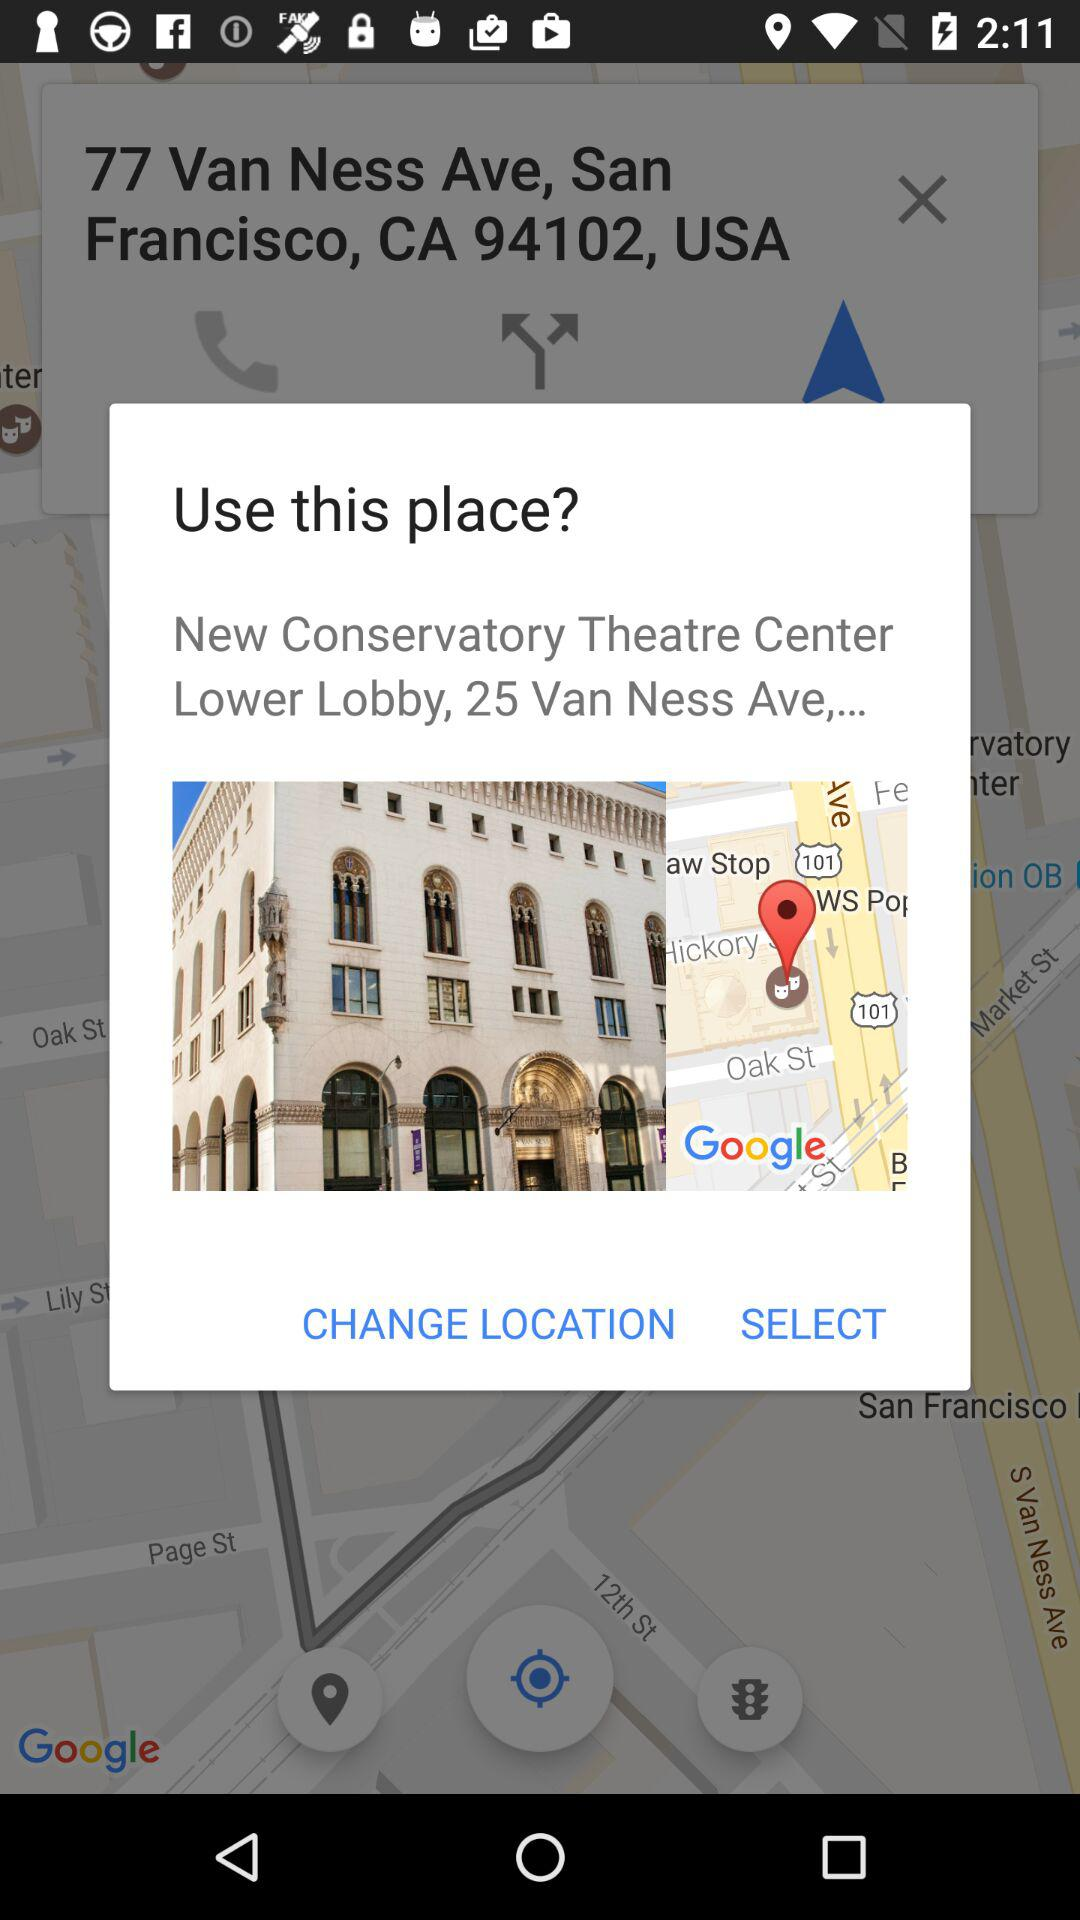What is the location? The locations are 77 Van Ness Ave, San Francisco, CA 94102, USA and "New Conservatory Theatre Center Lower Lobby, 25 Van Ness Ave,...". 